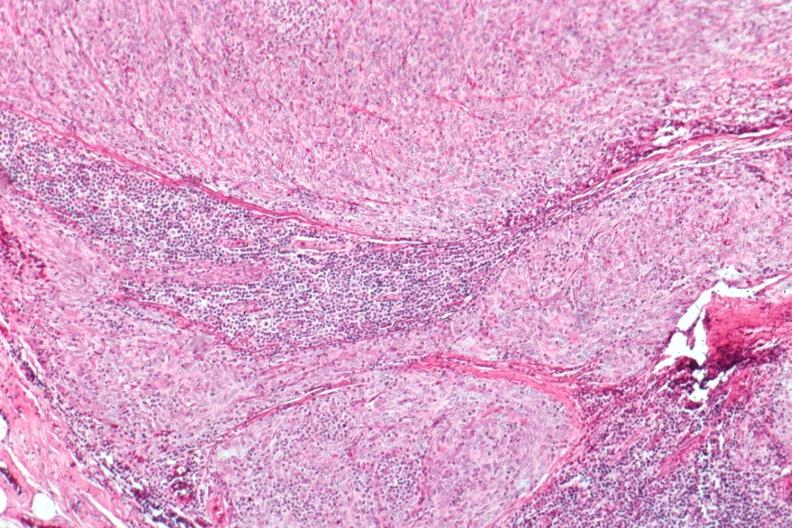does simian crease show epithelial predominant?
Answer the question using a single word or phrase. No 